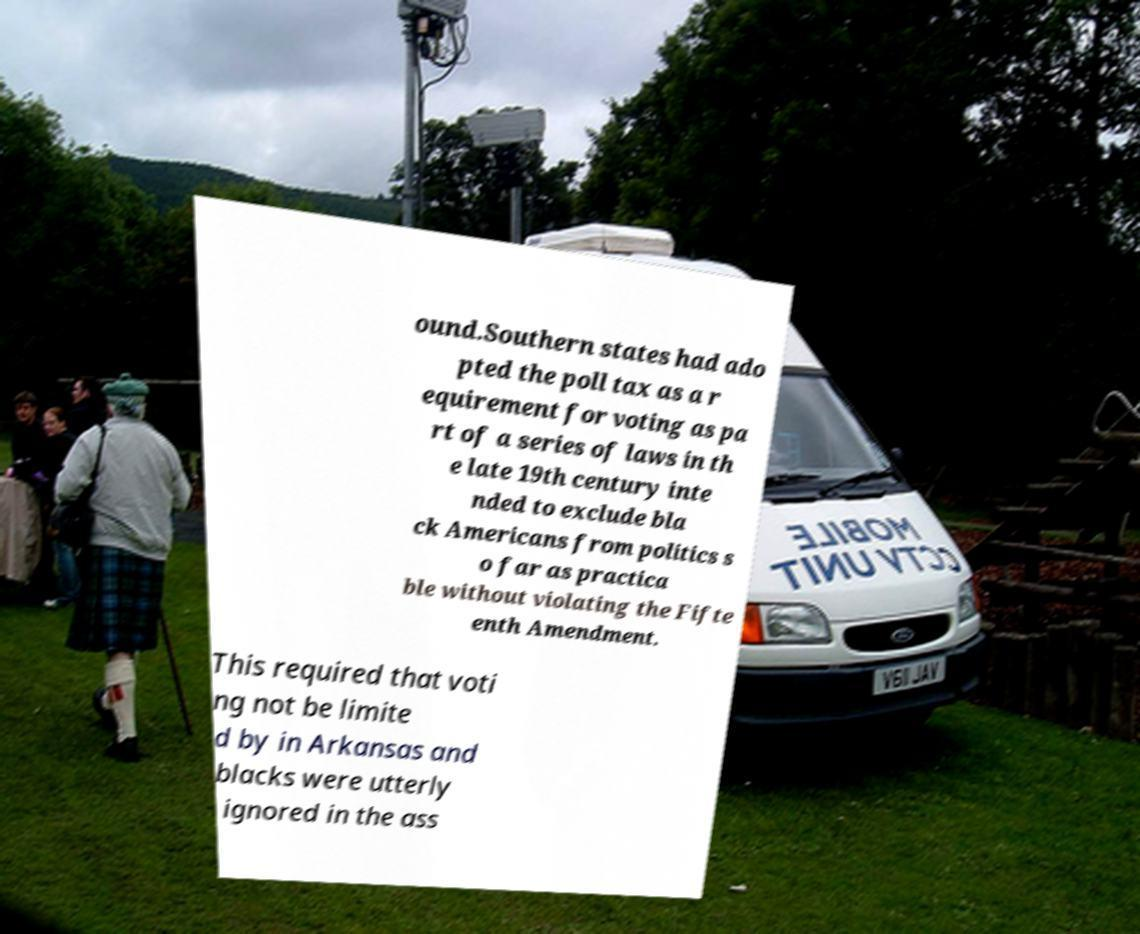I need the written content from this picture converted into text. Can you do that? ound.Southern states had ado pted the poll tax as a r equirement for voting as pa rt of a series of laws in th e late 19th century inte nded to exclude bla ck Americans from politics s o far as practica ble without violating the Fifte enth Amendment. This required that voti ng not be limite d by in Arkansas and blacks were utterly ignored in the ass 